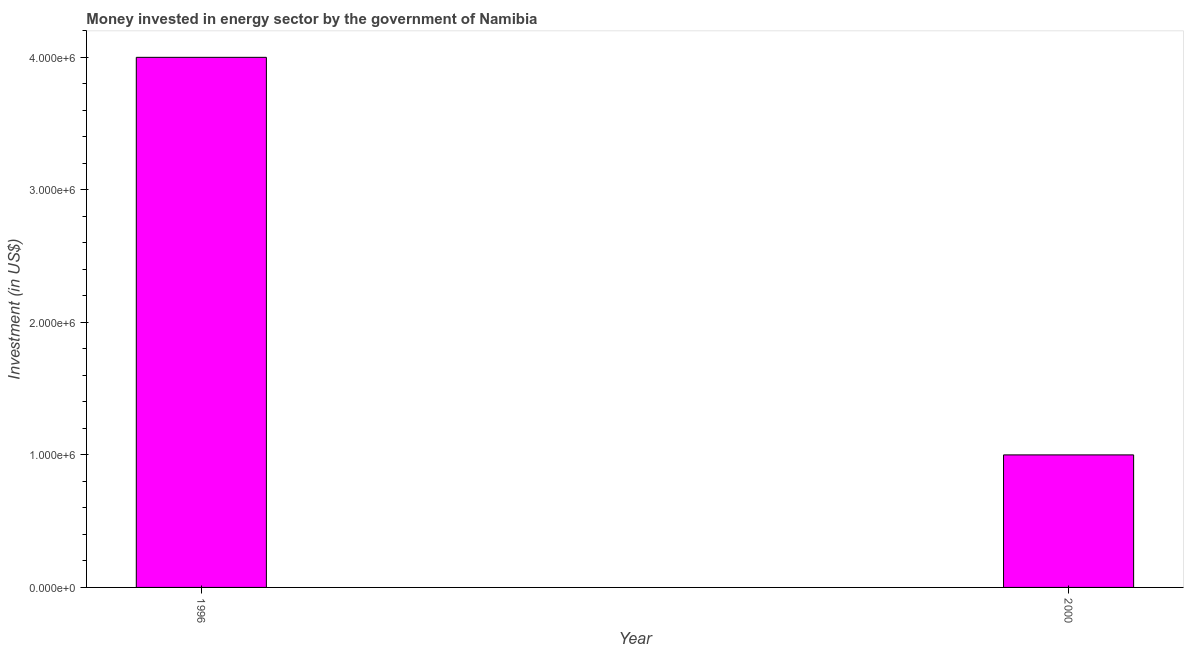Does the graph contain grids?
Your answer should be compact. No. What is the title of the graph?
Your answer should be very brief. Money invested in energy sector by the government of Namibia. What is the label or title of the Y-axis?
Provide a succinct answer. Investment (in US$). What is the investment in energy in 1996?
Provide a succinct answer. 4.00e+06. Across all years, what is the maximum investment in energy?
Your answer should be very brief. 4.00e+06. Across all years, what is the minimum investment in energy?
Ensure brevity in your answer.  1.00e+06. What is the difference between the investment in energy in 1996 and 2000?
Your answer should be compact. 3.00e+06. What is the average investment in energy per year?
Ensure brevity in your answer.  2.50e+06. What is the median investment in energy?
Offer a very short reply. 2.50e+06. In how many years, is the investment in energy greater than 4000000 US$?
Provide a succinct answer. 0. What is the ratio of the investment in energy in 1996 to that in 2000?
Give a very brief answer. 4. How many bars are there?
Offer a terse response. 2. Are all the bars in the graph horizontal?
Your response must be concise. No. What is the difference between two consecutive major ticks on the Y-axis?
Offer a very short reply. 1.00e+06. Are the values on the major ticks of Y-axis written in scientific E-notation?
Make the answer very short. Yes. What is the Investment (in US$) in 2000?
Keep it short and to the point. 1.00e+06. What is the difference between the Investment (in US$) in 1996 and 2000?
Provide a succinct answer. 3.00e+06. 